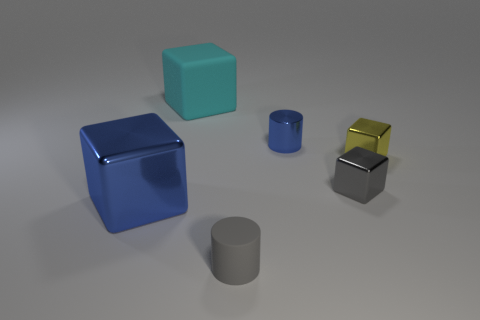The large object that is the same color as the small shiny cylinder is what shape?
Offer a terse response. Cube. What number of things are big balls or gray cubes?
Your answer should be very brief. 1. What color is the small cube that is left of the block right of the tiny gray shiny block that is right of the blue shiny block?
Your response must be concise. Gray. Is there anything else of the same color as the big metal thing?
Provide a succinct answer. Yes. Does the metal cylinder have the same size as the yellow block?
Keep it short and to the point. Yes. How many things are either shiny objects that are to the right of the tiny blue shiny cylinder or small things that are behind the gray matte object?
Your answer should be compact. 3. What is the small cylinder in front of the object to the right of the small gray block made of?
Give a very brief answer. Rubber. How many other objects are there of the same material as the blue block?
Ensure brevity in your answer.  3. Does the small yellow object have the same shape as the big cyan thing?
Ensure brevity in your answer.  Yes. There is a metallic block left of the cyan object; what size is it?
Your response must be concise. Large. 